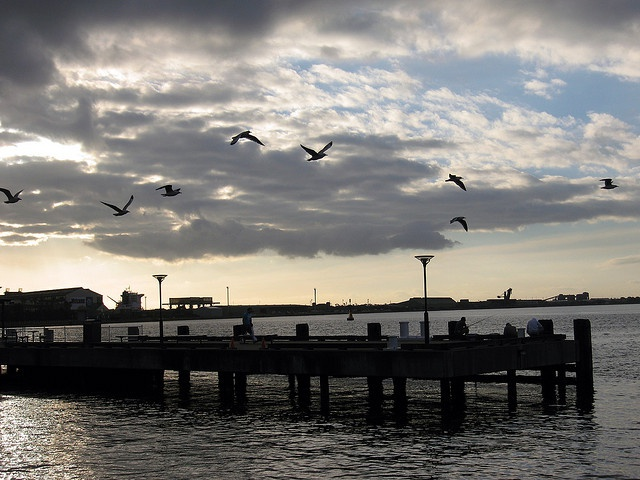Describe the objects in this image and their specific colors. I can see people in black and gray tones, people in black and gray tones, bird in black, gray, and darkgray tones, bird in black, white, gray, and darkgray tones, and bird in black and gray tones in this image. 